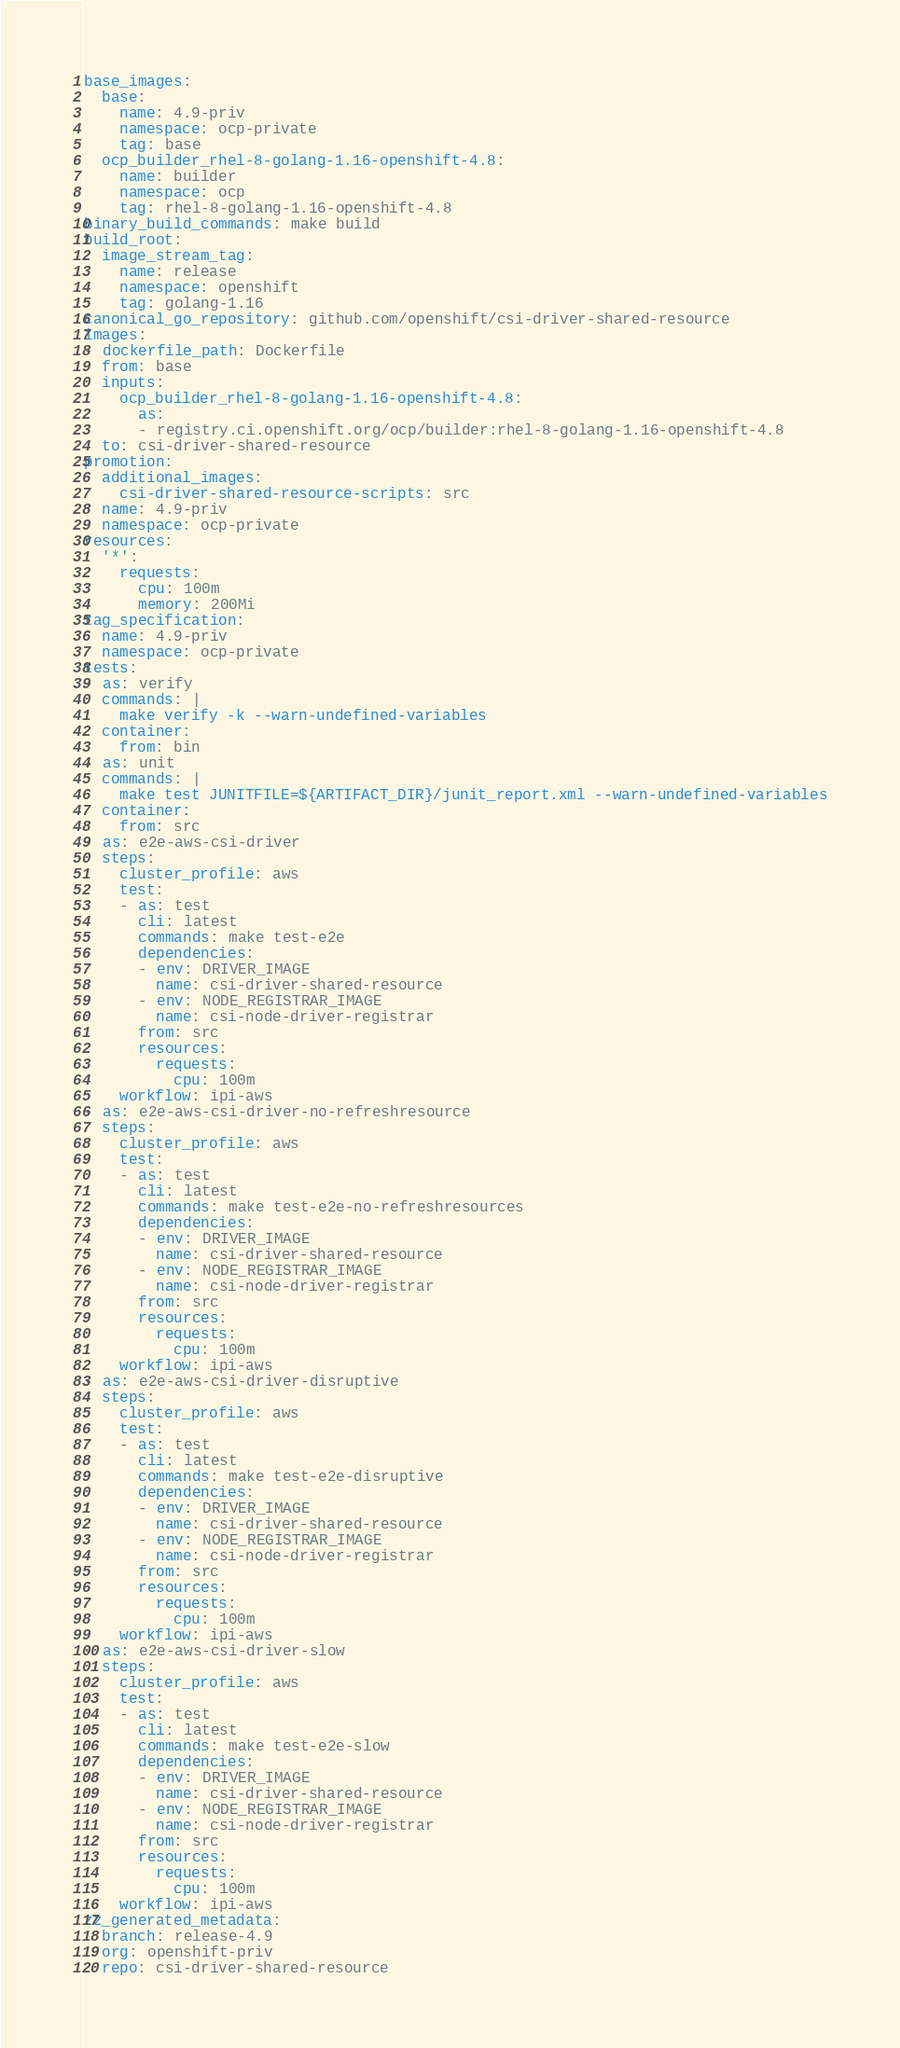<code> <loc_0><loc_0><loc_500><loc_500><_YAML_>base_images:
  base:
    name: 4.9-priv
    namespace: ocp-private
    tag: base
  ocp_builder_rhel-8-golang-1.16-openshift-4.8:
    name: builder
    namespace: ocp
    tag: rhel-8-golang-1.16-openshift-4.8
binary_build_commands: make build
build_root:
  image_stream_tag:
    name: release
    namespace: openshift
    tag: golang-1.16
canonical_go_repository: github.com/openshift/csi-driver-shared-resource
images:
- dockerfile_path: Dockerfile
  from: base
  inputs:
    ocp_builder_rhel-8-golang-1.16-openshift-4.8:
      as:
      - registry.ci.openshift.org/ocp/builder:rhel-8-golang-1.16-openshift-4.8
  to: csi-driver-shared-resource
promotion:
  additional_images:
    csi-driver-shared-resource-scripts: src
  name: 4.9-priv
  namespace: ocp-private
resources:
  '*':
    requests:
      cpu: 100m
      memory: 200Mi
tag_specification:
  name: 4.9-priv
  namespace: ocp-private
tests:
- as: verify
  commands: |
    make verify -k --warn-undefined-variables
  container:
    from: bin
- as: unit
  commands: |
    make test JUNITFILE=${ARTIFACT_DIR}/junit_report.xml --warn-undefined-variables
  container:
    from: src
- as: e2e-aws-csi-driver
  steps:
    cluster_profile: aws
    test:
    - as: test
      cli: latest
      commands: make test-e2e
      dependencies:
      - env: DRIVER_IMAGE
        name: csi-driver-shared-resource
      - env: NODE_REGISTRAR_IMAGE
        name: csi-node-driver-registrar
      from: src
      resources:
        requests:
          cpu: 100m
    workflow: ipi-aws
- as: e2e-aws-csi-driver-no-refreshresource
  steps:
    cluster_profile: aws
    test:
    - as: test
      cli: latest
      commands: make test-e2e-no-refreshresources
      dependencies:
      - env: DRIVER_IMAGE
        name: csi-driver-shared-resource
      - env: NODE_REGISTRAR_IMAGE
        name: csi-node-driver-registrar
      from: src
      resources:
        requests:
          cpu: 100m
    workflow: ipi-aws
- as: e2e-aws-csi-driver-disruptive
  steps:
    cluster_profile: aws
    test:
    - as: test
      cli: latest
      commands: make test-e2e-disruptive
      dependencies:
      - env: DRIVER_IMAGE
        name: csi-driver-shared-resource
      - env: NODE_REGISTRAR_IMAGE
        name: csi-node-driver-registrar
      from: src
      resources:
        requests:
          cpu: 100m
    workflow: ipi-aws
- as: e2e-aws-csi-driver-slow
  steps:
    cluster_profile: aws
    test:
    - as: test
      cli: latest
      commands: make test-e2e-slow
      dependencies:
      - env: DRIVER_IMAGE
        name: csi-driver-shared-resource
      - env: NODE_REGISTRAR_IMAGE
        name: csi-node-driver-registrar
      from: src
      resources:
        requests:
          cpu: 100m
    workflow: ipi-aws
zz_generated_metadata:
  branch: release-4.9
  org: openshift-priv
  repo: csi-driver-shared-resource
</code> 